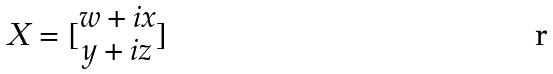Convert formula to latex. <formula><loc_0><loc_0><loc_500><loc_500>X = [ \begin{matrix} w + i x \\ y + i z \end{matrix} ]</formula> 